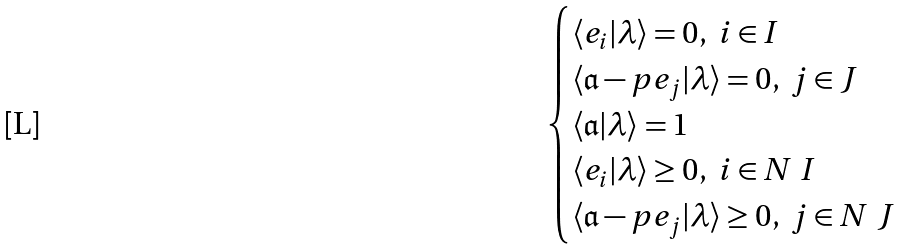<formula> <loc_0><loc_0><loc_500><loc_500>\begin{cases} \langle e _ { i } | \lambda \rangle = 0 , \ i \in I \\ \langle \mathfrak a - p e _ { j } | \lambda \rangle = 0 , \ j \in J \\ \langle \mathfrak a | \lambda \rangle = 1 \\ \langle e _ { i } | \lambda \rangle \geq 0 , \ i \in N \ I \\ \langle \mathfrak a - p e _ { j } | \lambda \rangle \geq 0 , \ j \in N \ J \end{cases}</formula> 